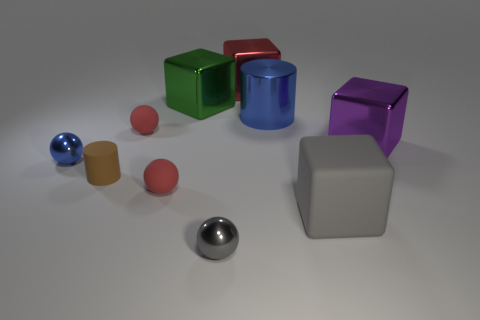Subtract all cylinders. How many objects are left? 8 Subtract all green cubes. How many cubes are left? 3 Subtract all large purple metal cubes. How many cubes are left? 3 Subtract 1 brown cylinders. How many objects are left? 9 Subtract 2 cylinders. How many cylinders are left? 0 Subtract all red spheres. Subtract all green cubes. How many spheres are left? 2 Subtract all green spheres. How many gray blocks are left? 1 Subtract all blue matte objects. Subtract all big cylinders. How many objects are left? 9 Add 3 cubes. How many cubes are left? 7 Add 2 small rubber cylinders. How many small rubber cylinders exist? 3 